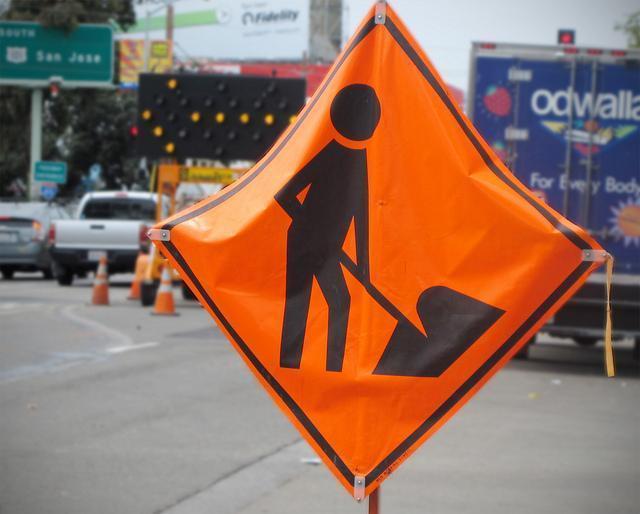How many trucks can be seen?
Give a very brief answer. 2. How many zebras have their faces showing in the image?
Give a very brief answer. 0. 